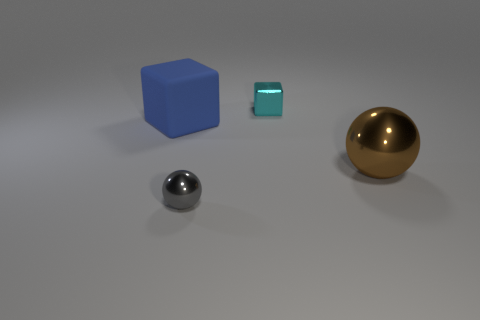There is a big thing behind the big metallic sphere; does it have the same shape as the thing that is in front of the big brown sphere?
Provide a succinct answer. No. There is a small metallic object in front of the big object that is in front of the blue object; what is its shape?
Make the answer very short. Sphere. What size is the object that is both in front of the blue rubber thing and on the left side of the small cyan metallic object?
Your answer should be very brief. Small. There is a tiny cyan object; is it the same shape as the shiny object to the left of the cyan metallic cube?
Offer a terse response. No. The other object that is the same shape as the large metal thing is what size?
Make the answer very short. Small. Is the color of the big metallic object the same as the tiny shiny object that is right of the gray sphere?
Provide a short and direct response. No. What number of other objects are the same size as the blue rubber block?
Make the answer very short. 1. The big thing that is left of the tiny thing that is left of the thing that is behind the blue thing is what shape?
Make the answer very short. Cube. Is the size of the brown sphere the same as the ball in front of the brown ball?
Offer a terse response. No. What is the color of the thing that is on the left side of the small metallic cube and to the right of the blue rubber cube?
Offer a very short reply. Gray. 